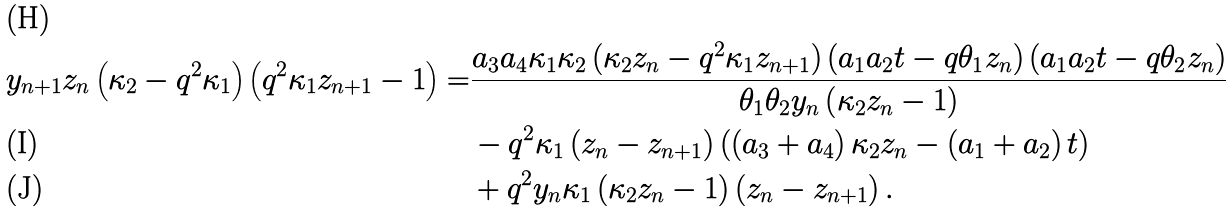Convert formula to latex. <formula><loc_0><loc_0><loc_500><loc_500>y _ { n + 1 } z _ { n } \left ( \kappa _ { 2 } - q ^ { 2 } \kappa _ { 1 } \right ) \left ( q ^ { 2 } \kappa _ { 1 } z _ { n + 1 } - 1 \right ) = & \frac { a _ { 3 } a _ { 4 } \kappa _ { 1 } \kappa _ { 2 } \left ( \kappa _ { 2 } z _ { n } - q ^ { 2 } \kappa _ { 1 } z _ { n + 1 } \right ) \left ( a _ { 1 } a _ { 2 } t - q \theta _ { 1 } z _ { n } \right ) \left ( a _ { 1 } a _ { 2 } t - q \theta _ { 2 } z _ { n } \right ) } { \theta _ { 1 } \theta _ { 2 } y _ { n } \left ( \kappa _ { 2 } z _ { n } - 1 \right ) } \\ & - q ^ { 2 } \kappa _ { 1 } \left ( z _ { n } - z _ { n + 1 } \right ) \left ( \left ( a _ { 3 } + a _ { 4 } \right ) \kappa _ { 2 } z _ { n } - \left ( a _ { 1 } + a _ { 2 } \right ) t \right ) \\ & + q ^ { 2 } y _ { n } \kappa _ { 1 } \left ( \kappa _ { 2 } z _ { n } - 1 \right ) \left ( z _ { n } - z _ { n + 1 } \right ) .</formula> 